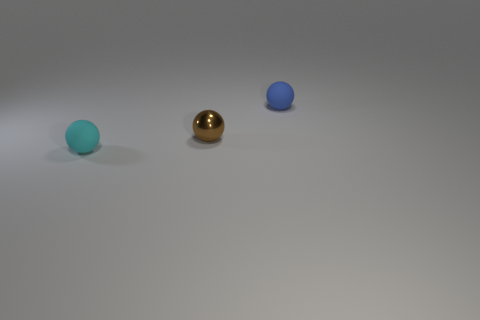The other thing that is the same material as the small blue object is what size?
Provide a succinct answer. Small. Are the small cyan sphere and the small blue object made of the same material?
Your answer should be very brief. Yes. How many blue spheres are to the left of the matte sphere that is in front of the tiny blue thing?
Make the answer very short. 0. Is there anything else that has the same material as the brown thing?
Your response must be concise. No. Is the material of the small blue sphere the same as the small ball to the left of the brown metal thing?
Your answer should be compact. Yes. Is the number of tiny cyan matte spheres that are right of the brown metal ball less than the number of tiny cyan matte balls right of the blue matte ball?
Your answer should be compact. No. What material is the tiny brown sphere on the left side of the blue rubber sphere?
Make the answer very short. Metal. What is the color of the sphere that is behind the cyan rubber sphere and in front of the small blue matte ball?
Your answer should be very brief. Brown. How many other things are the same color as the metallic sphere?
Your response must be concise. 0. What is the color of the tiny matte thing that is behind the cyan thing?
Offer a very short reply. Blue. 